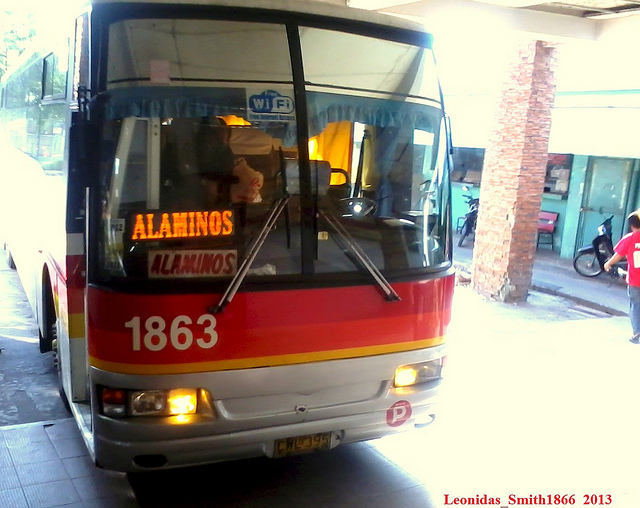<image>What are the dimensions of the front two windows on the bus? I am not sure about the dimensions of the front two windows on the bus. It can be '5 by 3', '3 by 4', '4 feet by 4 feet', '4 x 5 ft', '3 feet by 4 feet' or '6 by 10 inches'. What are the dimensions of the front two windows on the bus? I don't know the dimensions of the front two windows on the bus. It could be any of the given options. 